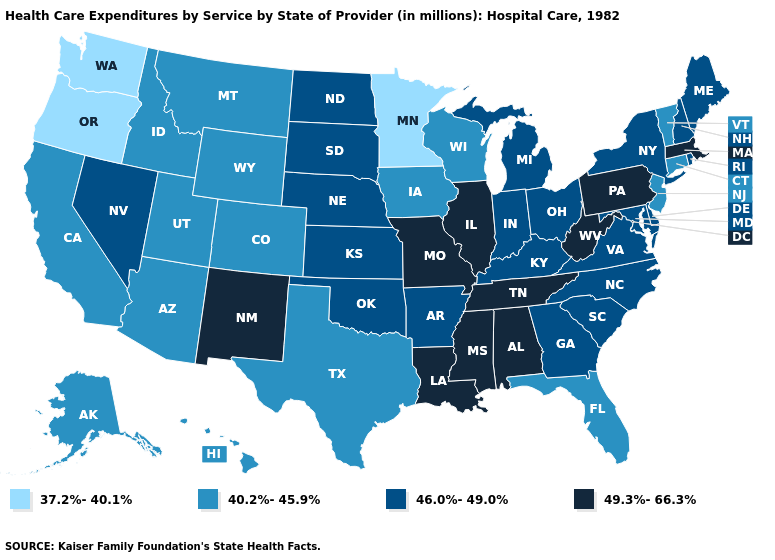Is the legend a continuous bar?
Be succinct. No. Among the states that border Idaho , does Utah have the lowest value?
Give a very brief answer. No. Is the legend a continuous bar?
Write a very short answer. No. Among the states that border Florida , which have the highest value?
Quick response, please. Alabama. Does West Virginia have the highest value in the USA?
Quick response, please. Yes. Among the states that border Tennessee , which have the highest value?
Keep it brief. Alabama, Mississippi, Missouri. What is the lowest value in states that border Wisconsin?
Concise answer only. 37.2%-40.1%. Does Minnesota have the lowest value in the USA?
Keep it brief. Yes. Does Kentucky have a higher value than Georgia?
Be succinct. No. What is the lowest value in states that border Texas?
Answer briefly. 46.0%-49.0%. Does Washington have the lowest value in the USA?
Answer briefly. Yes. Does Maine have a lower value than Michigan?
Write a very short answer. No. What is the lowest value in the Northeast?
Concise answer only. 40.2%-45.9%. Which states have the highest value in the USA?
Quick response, please. Alabama, Illinois, Louisiana, Massachusetts, Mississippi, Missouri, New Mexico, Pennsylvania, Tennessee, West Virginia. 